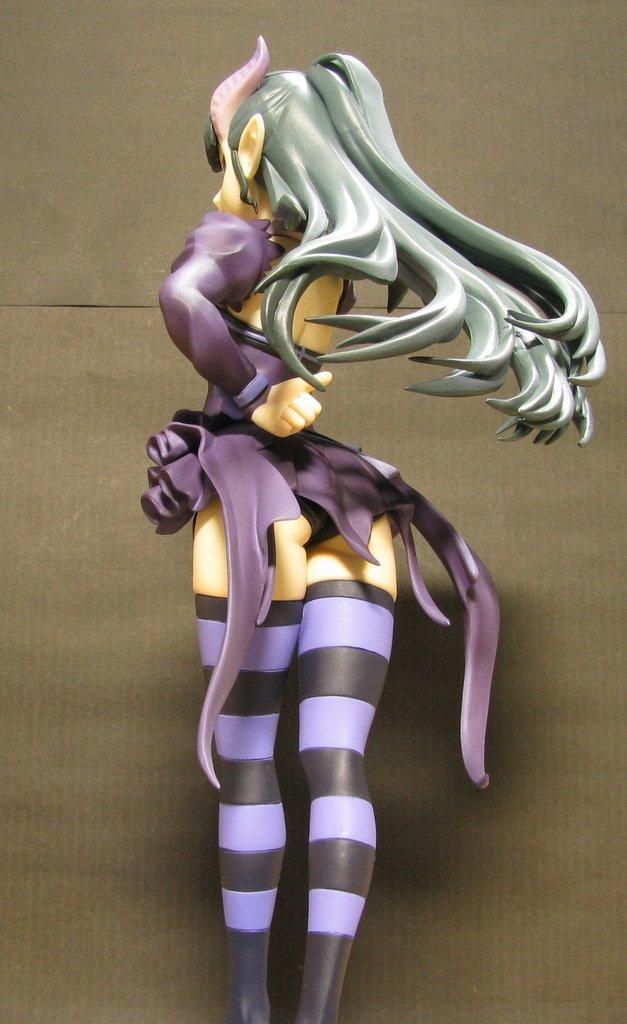What type of character is present in the image? There is an animated woman in the image. What type of roof is visible above the animated woman in the image? There is no roof visible in the image, as it only features an animated woman. What is the animated woman doing in the image, such as blowing a kiss or performing a task? The provided facts do not mention any specific actions or tasks being performed by the animated woman, so it cannot be determined from the image. 